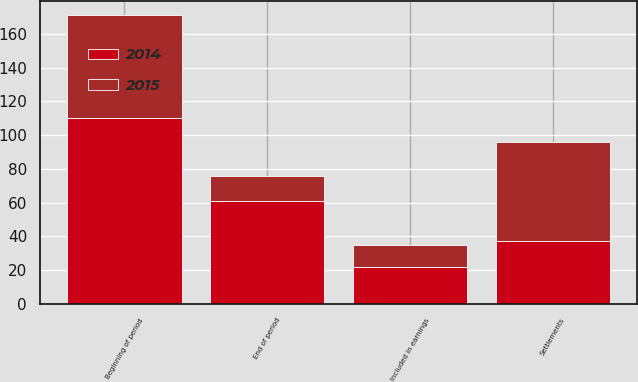<chart> <loc_0><loc_0><loc_500><loc_500><stacked_bar_chart><ecel><fcel>Beginning of period<fcel>Included in earnings<fcel>Settlements<fcel>End of period<nl><fcel>2015<fcel>61<fcel>13<fcel>59<fcel>15<nl><fcel>2014<fcel>110<fcel>22<fcel>37<fcel>61<nl></chart> 